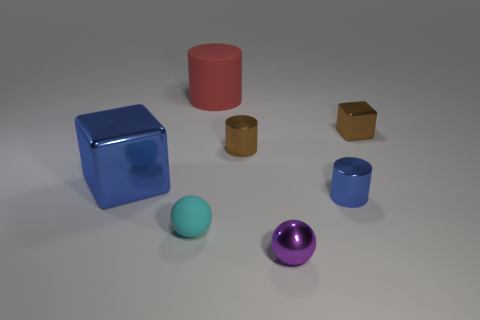There is a small object that is the same color as the large metallic object; what is its material? The small object that shares its blue color with the larger cube is also made of metal, exhibiting a similar reflective surface and visual texture that characterize metallic materials. 